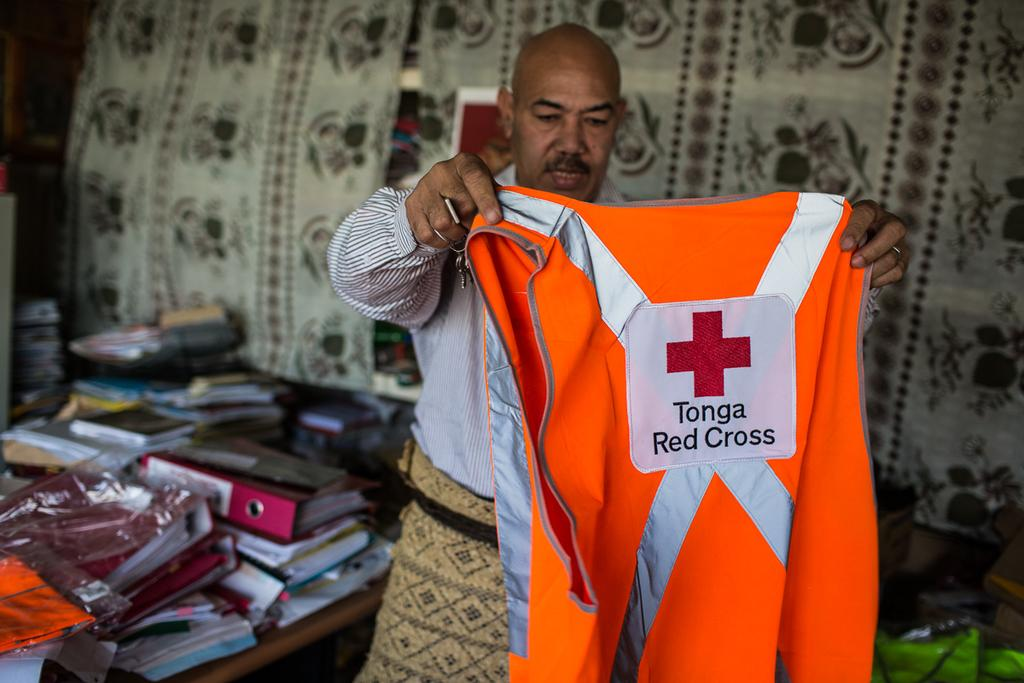<image>
Describe the image concisely. A man holds a vest from the Tonga Red Cross. 